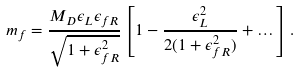<formula> <loc_0><loc_0><loc_500><loc_500>m _ { f } = \frac { M _ { D } \epsilon _ { L } \epsilon _ { f R } } { \sqrt { 1 + \epsilon _ { f R } ^ { 2 } } } \left [ 1 - \frac { \epsilon _ { L } ^ { 2 } } { 2 ( 1 + \epsilon _ { f R } ^ { 2 } ) } + \dots \right ] .</formula> 